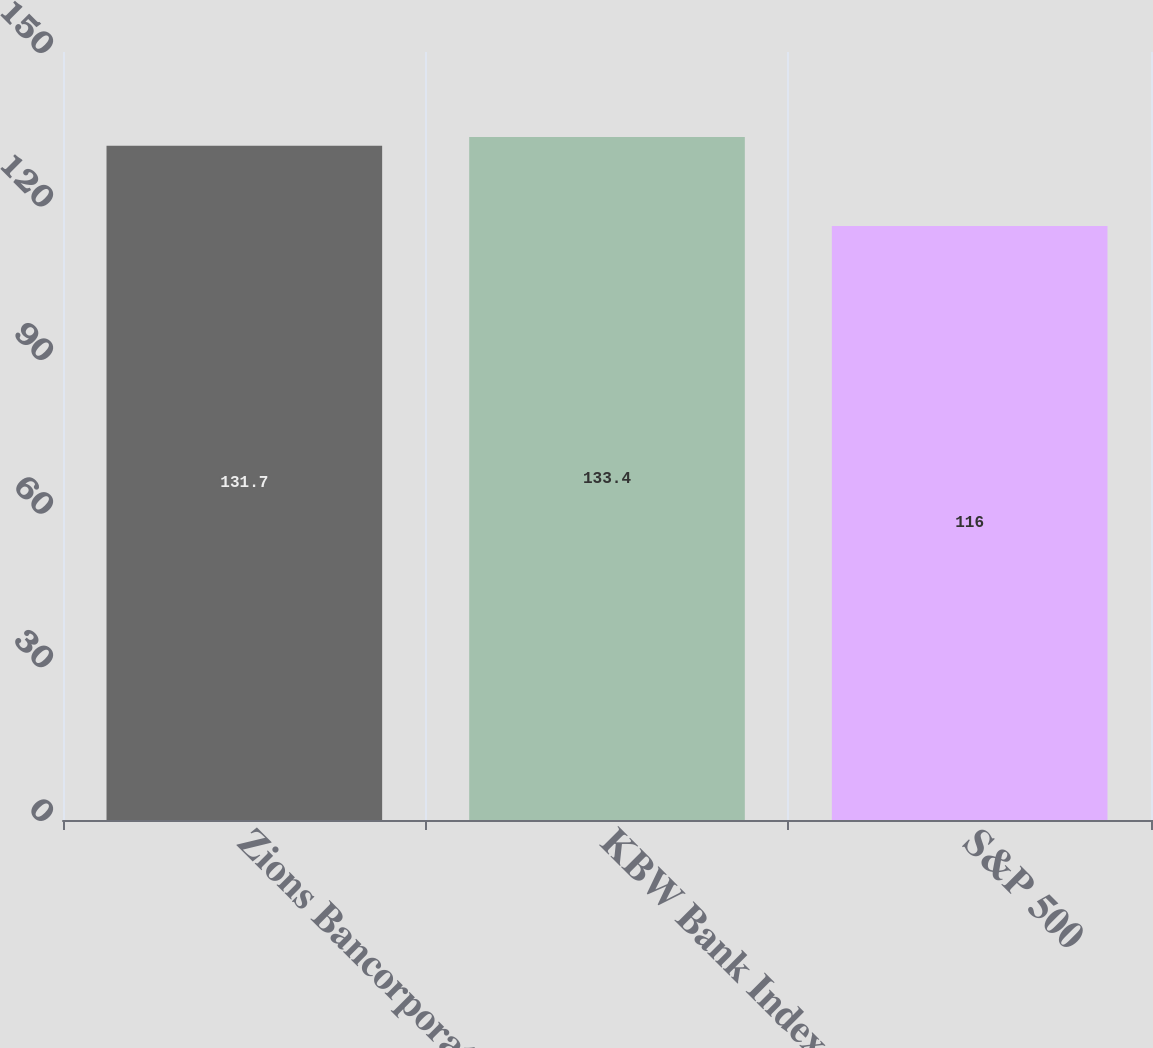<chart> <loc_0><loc_0><loc_500><loc_500><bar_chart><fcel>Zions Bancorporation<fcel>KBW Bank Index<fcel>S&P 500<nl><fcel>131.7<fcel>133.4<fcel>116<nl></chart> 